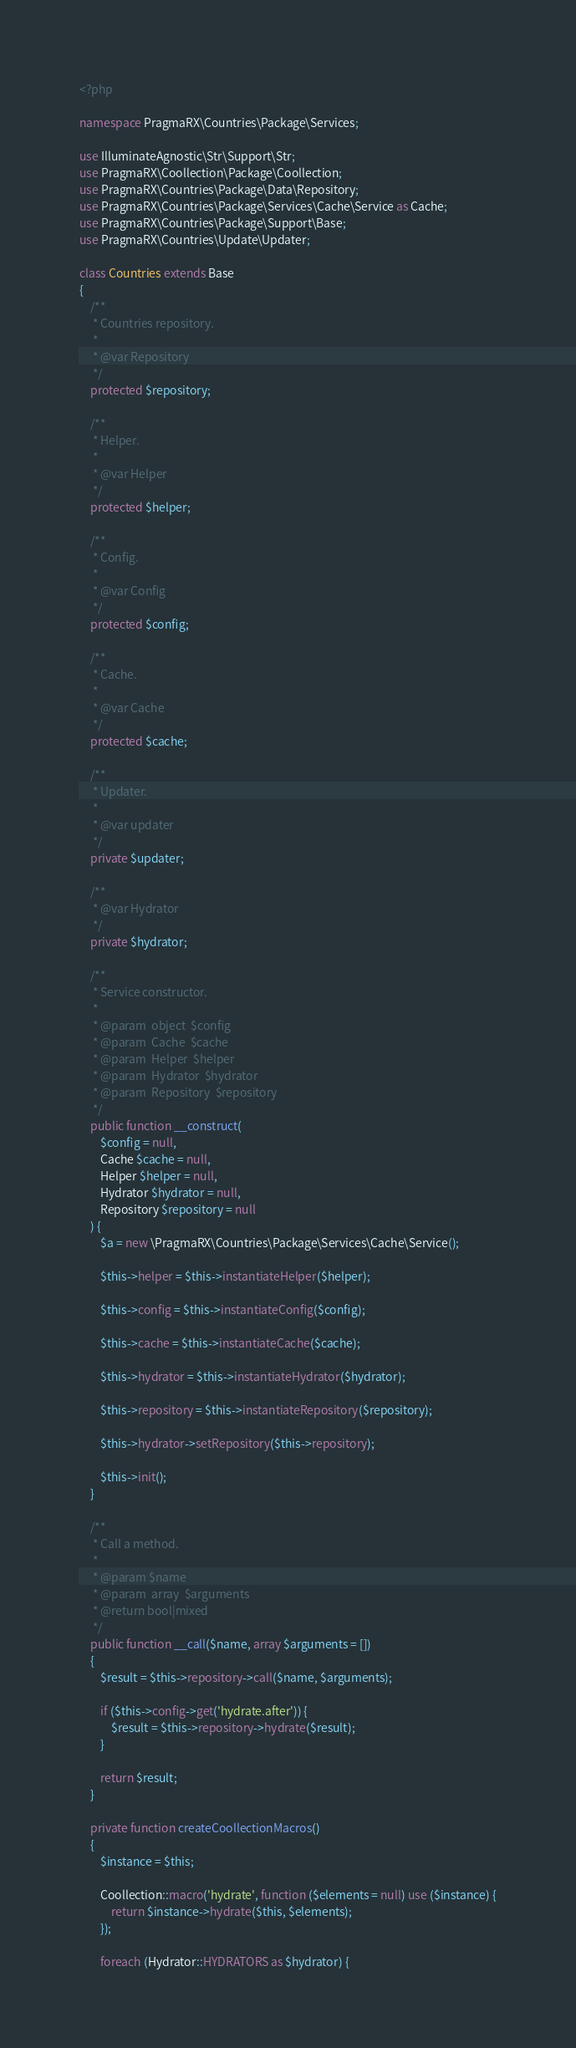<code> <loc_0><loc_0><loc_500><loc_500><_PHP_><?php

namespace PragmaRX\Countries\Package\Services;

use IlluminateAgnostic\Str\Support\Str;
use PragmaRX\Coollection\Package\Coollection;
use PragmaRX\Countries\Package\Data\Repository;
use PragmaRX\Countries\Package\Services\Cache\Service as Cache;
use PragmaRX\Countries\Package\Support\Base;
use PragmaRX\Countries\Update\Updater;

class Countries extends Base
{
    /**
     * Countries repository.
     *
     * @var Repository
     */
    protected $repository;

    /**
     * Helper.
     *
     * @var Helper
     */
    protected $helper;

    /**
     * Config.
     *
     * @var Config
     */
    protected $config;

    /**
     * Cache.
     *
     * @var Cache
     */
    protected $cache;

    /**
     * Updater.
     *
     * @var updater
     */
    private $updater;

    /**
     * @var Hydrator
     */
    private $hydrator;

    /**
     * Service constructor.
     *
     * @param  object  $config
     * @param  Cache  $cache
     * @param  Helper  $helper
     * @param  Hydrator  $hydrator
     * @param  Repository  $repository
     */
    public function __construct(
        $config = null,
        Cache $cache = null,
        Helper $helper = null,
        Hydrator $hydrator = null,
        Repository $repository = null
    ) {
        $a = new \PragmaRX\Countries\Package\Services\Cache\Service();

        $this->helper = $this->instantiateHelper($helper);

        $this->config = $this->instantiateConfig($config);

        $this->cache = $this->instantiateCache($cache);

        $this->hydrator = $this->instantiateHydrator($hydrator);

        $this->repository = $this->instantiateRepository($repository);

        $this->hydrator->setRepository($this->repository);

        $this->init();
    }

    /**
     * Call a method.
     *
     * @param $name
     * @param  array  $arguments
     * @return bool|mixed
     */
    public function __call($name, array $arguments = [])
    {
        $result = $this->repository->call($name, $arguments);

        if ($this->config->get('hydrate.after')) {
            $result = $this->repository->hydrate($result);
        }

        return $result;
    }

    private function createCoollectionMacros()
    {
        $instance = $this;

        Coollection::macro('hydrate', function ($elements = null) use ($instance) {
            return $instance->hydrate($this, $elements);
        });

        foreach (Hydrator::HYDRATORS as $hydrator) {</code> 